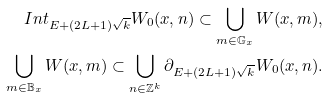Convert formula to latex. <formula><loc_0><loc_0><loc_500><loc_500>I n t _ { E + ( 2 L + 1 ) \sqrt { k } } W _ { 0 } ( x , n ) \subset \bigcup _ { m \in \mathbb { G } _ { x } } W ( x , m ) , \\ \bigcup _ { m \in \mathbb { B } _ { x } } W ( x , m ) \subset \bigcup _ { n \in \mathbb { Z } ^ { k } } \partial _ { E + ( 2 L + 1 ) \sqrt { k } } W _ { 0 } ( x , n ) .</formula> 